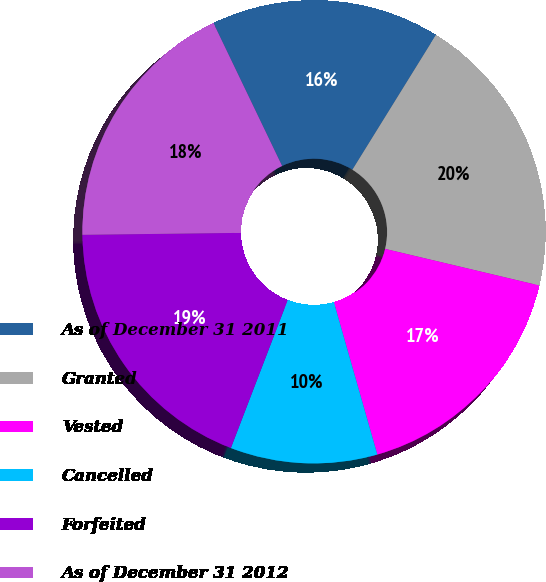<chart> <loc_0><loc_0><loc_500><loc_500><pie_chart><fcel>As of December 31 2011<fcel>Granted<fcel>Vested<fcel>Cancelled<fcel>Forfeited<fcel>As of December 31 2012<nl><fcel>15.96%<fcel>19.88%<fcel>16.87%<fcel>10.26%<fcel>18.97%<fcel>18.07%<nl></chart> 